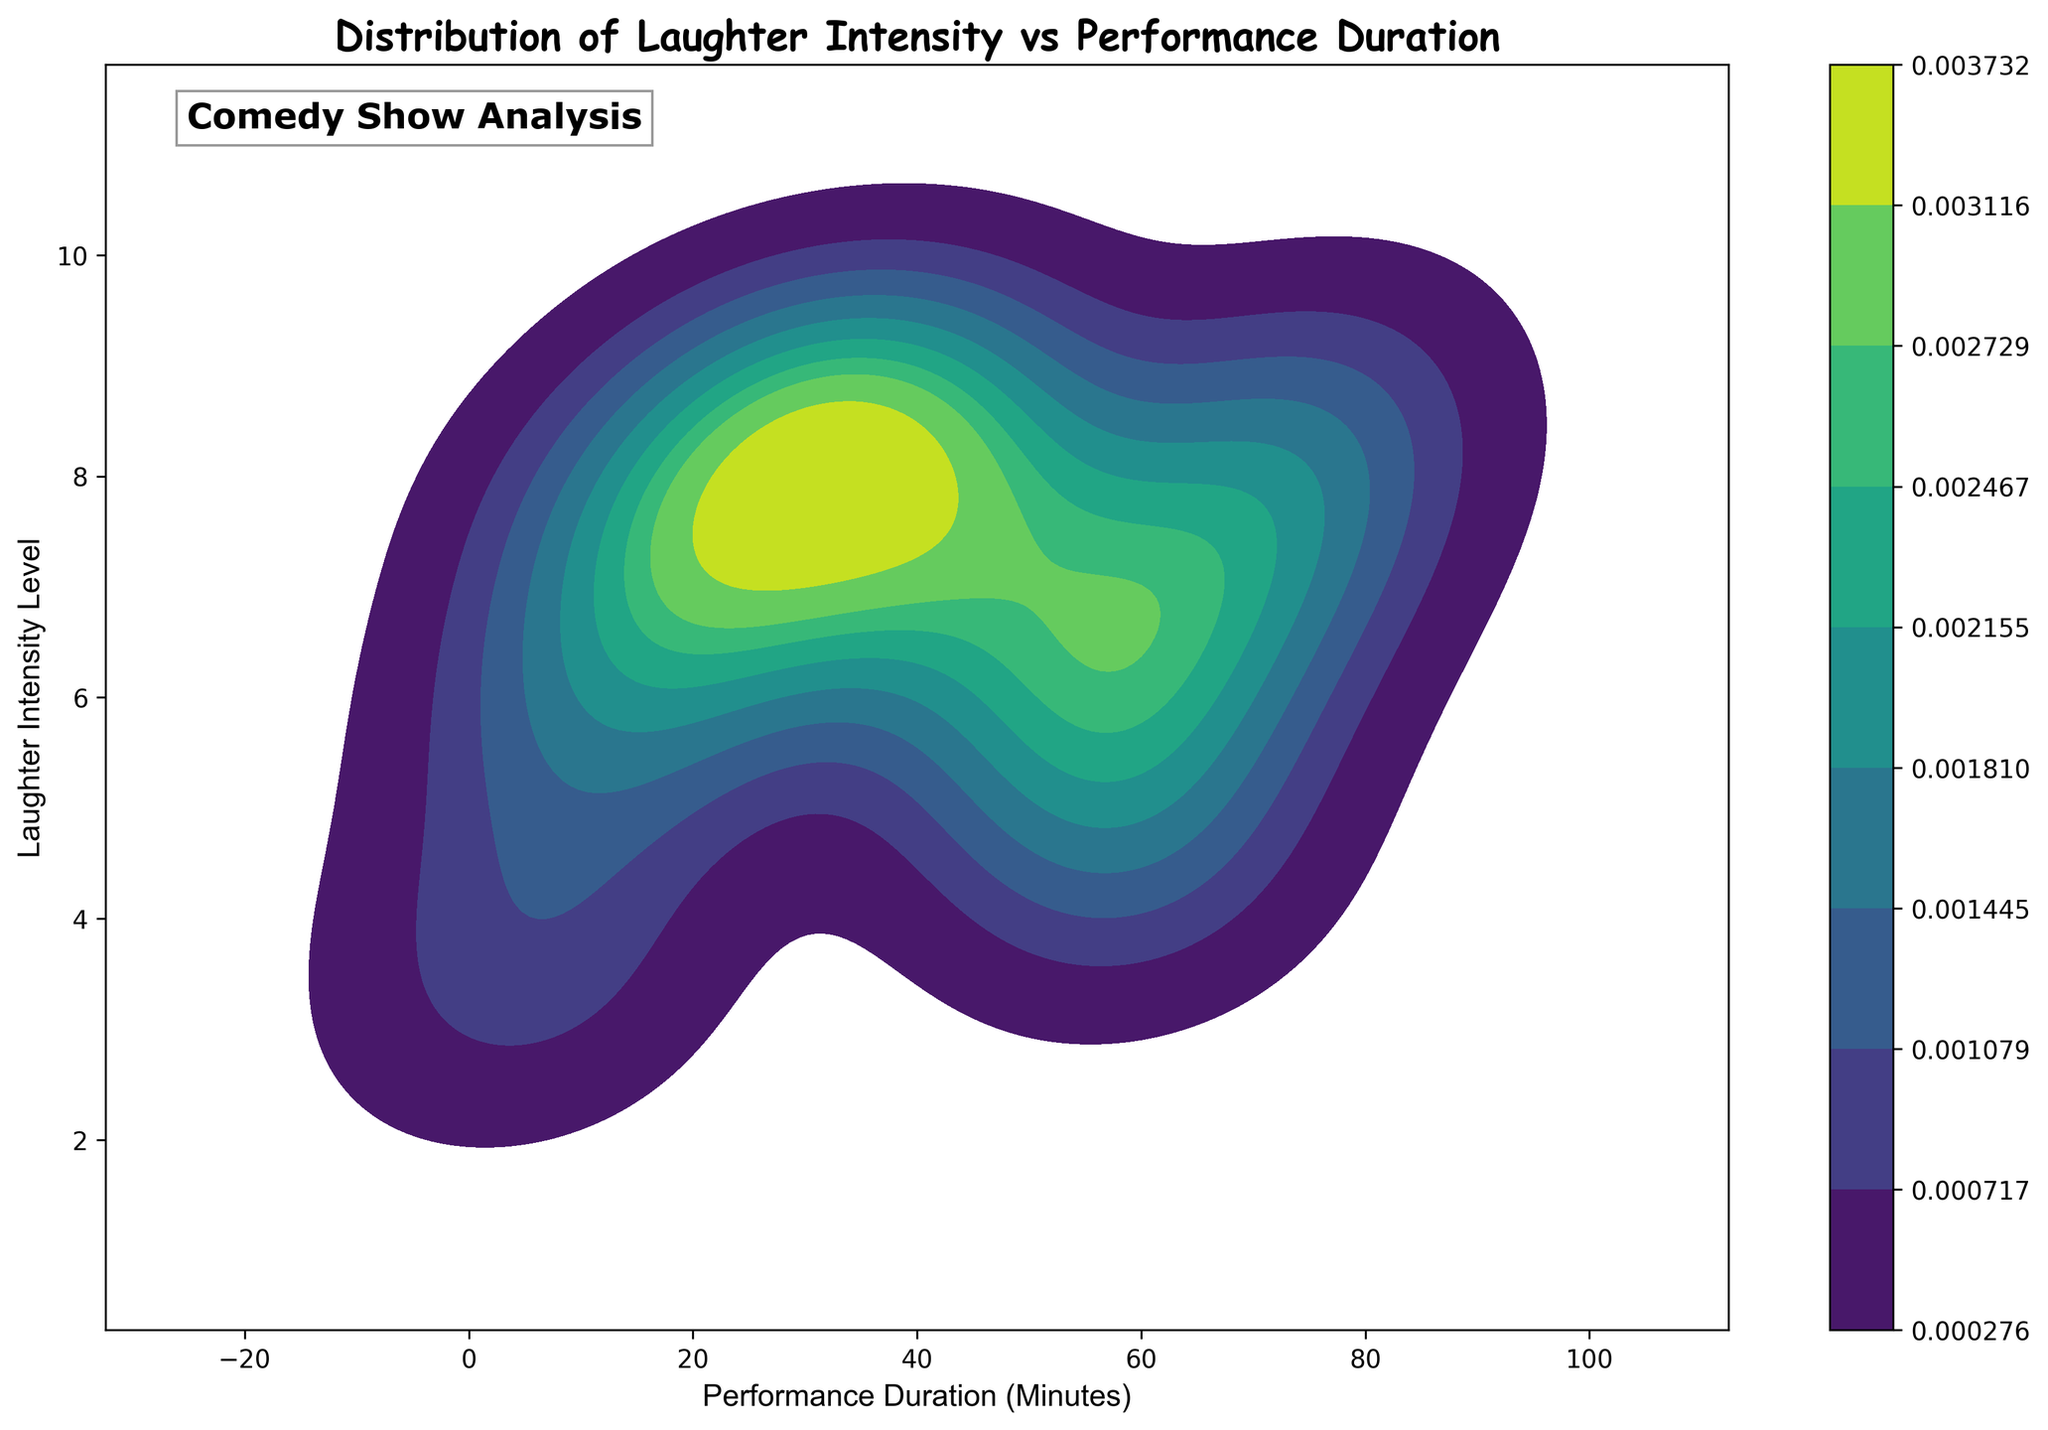What's the title of the figure? The title of the figure is prominently displayed at the top. It is usually larger in font size and bold to make it easily identifiable.
Answer: Distribution of Laughter Intensity vs Performance Duration What does the x-axis represent? The label for the x-axis is usually found underneath the horizontal line of the plot. This label specifies the variable that the axis represents.
Answer: Performance Duration (Minutes) What does the y-axis represent? The label for the y-axis is typically located along the vertical line of the plot. This label indicates the variable that the axis represents.
Answer: Laughter Intensity Level What color scheme is used in the plot? The color scheme or palette often appears in a legend or is indicated by the colors within the plot itself. In this plot, the color scheme is used to indicate the density.
Answer: Viridis How does the laughter intensity change as the performance duration increases? To determine this, look at the trend of the color density. Higher density areas (darker colors) show regions of higher laughter intensity corresponding to performance duration.
Answer: Laughter intensity generally increases with performance duration Which performance duration ranges have the highest laughter intensity levels? Identify the areas where the color density is highest. These areas indicate where laughter intensity is most frequent. The highest laughter intensity levels correspond to the darkest areas.
Answer: 50-75 minutes Is there a noticeable pattern in the laughter intensity levels when comparing shorter to longer performance durations? Analyze the progression from shortest to longest performance durations, observing the changes in laughter intensity shown by the color gradients on the plot. This gives insight into how laughter intensity evolves over time.
Answer: Laughter intensity tends to increase and then stabilize In how many places on the plot is there a laughter intensity level of 9? By referring to specific spots where the y-axis shows a level of 9, count these points along the x-axis. These regions indicate where the laughter intensity level reaches 9.
Answer: 6 places What is the most common laughter intensity level for performance durations of around 60 minutes? Find the area around 60 minutes on the x-axis and observe the y-axis intersection where the highest color density is present. This identifies the most frequent laughter intensity level.
Answer: 5-6 Which duration shows the broadest range of laughter intensity levels? Search for the duration range that spans the most vertical space (y-axis) in the plot. This range will have laughter intensity levels covering the widest spectrum.
Answer: 55-65 minutes 